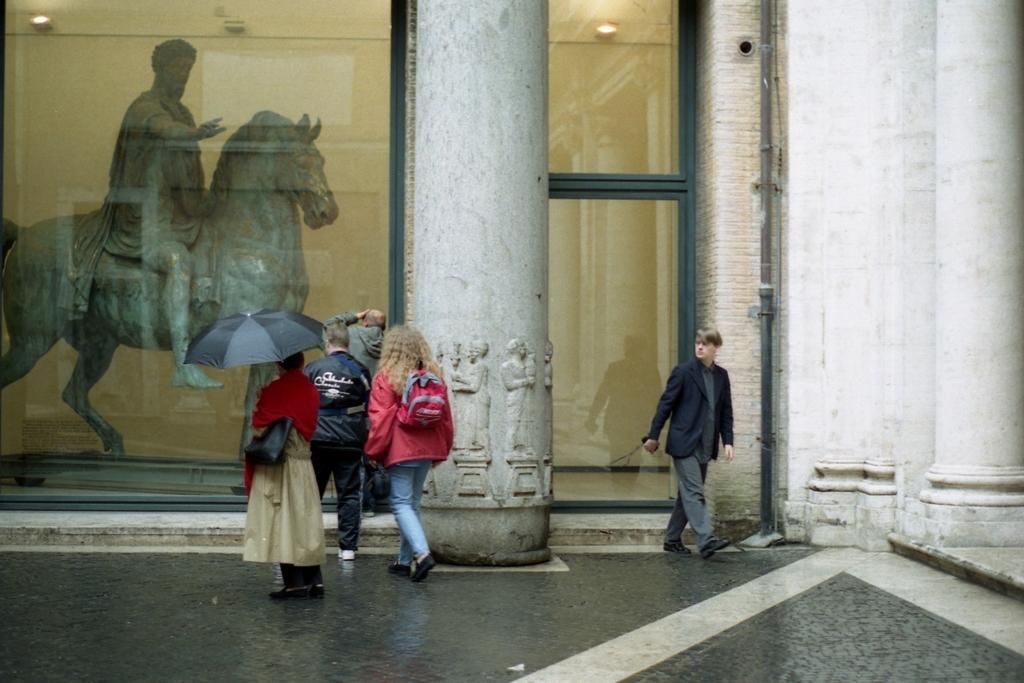Please provide a concise description of this image. In this image I can see people among them some are carrying carrying a bag and this woman is holding an umbrella. In the background, I can see a statue, framed glass wall, a pipe attached to the wall and pillars. 